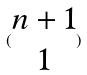Convert formula to latex. <formula><loc_0><loc_0><loc_500><loc_500>( \begin{matrix} n + 1 \\ 1 \end{matrix} )</formula> 